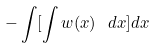<formula> <loc_0><loc_0><loc_500><loc_500>- \int [ \int w ( x ) \ \, d x ] d x</formula> 